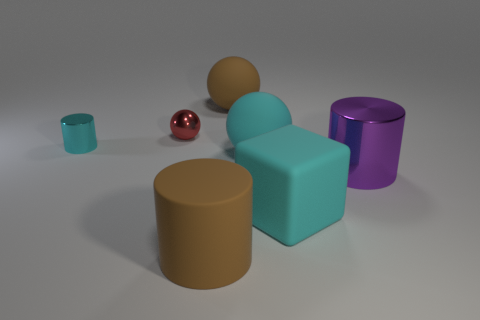Are there the same number of large spheres in front of the brown rubber sphere and objects that are right of the purple cylinder?
Give a very brief answer. No. Does the sphere behind the red sphere have the same size as the thing that is in front of the block?
Provide a succinct answer. Yes. There is a large object that is behind the large block and in front of the cyan ball; what is it made of?
Your answer should be very brief. Metal. Are there fewer large cylinders than cyan matte blocks?
Provide a short and direct response. No. How big is the brown rubber object on the left side of the big brown object behind the matte cylinder?
Provide a short and direct response. Large. What shape is the large brown matte thing that is in front of the large block that is behind the large brown rubber object that is in front of the large purple shiny thing?
Your answer should be very brief. Cylinder. What is the color of the tiny cylinder that is the same material as the large purple thing?
Make the answer very short. Cyan. The shiny cylinder that is behind the large cylinder that is to the right of the brown object in front of the large brown matte sphere is what color?
Provide a short and direct response. Cyan. What number of cylinders are either large brown matte objects or big purple things?
Your answer should be very brief. 2. There is a tiny cylinder that is the same color as the cube; what is it made of?
Give a very brief answer. Metal. 